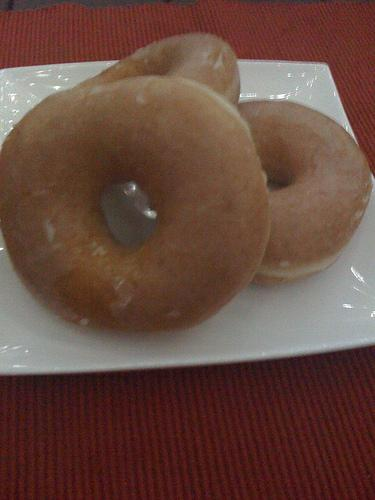Present a brief description of the food exhibited in the picture and its context. Three stacked donuts with glaze and holes in the center sit on a white plate, which lies on a distinct red table mat with ripples. Mention the central items present in the picture and their state. Three glazed doughnuts are placed together on a white square plate, resting on a red striped table mat. Point out the characteristics of the scene, particularly the doughnuts and the plate they are on. Three donuts with glaze and yellow edges are arranged on a glazed white square plate with light reflecting on its surface. Describe the setting where the delicious treats are served. A gray table holds a threaded red table mat with white, black, and red stripes, on which rests a square white plate carrying three doughnuts. Describe the image, highlighting its main features and how they all come together. Three doughnuts, touching each other and covered in glaze, rest on a glass square white plate with light reflections, surrounded by a red-striped mat. Talk about the primary objects in the photo, focusing on their appearance and surroundings. A trio of round donuts with white markings on top are showcased together on a reflective white plate atop a red cloth with wripples. Explain the color scheme and the visual features of the objects in the picture. The image displays three shiny glazed doughnuts on a square, glass white plate that reflects light, set on a red table mat with lines. Illustrate the arrangement of the doughnuts and the ambiance of the scene. The image captures three donuts, one fully facing the camera, and the other two angled, placed together on a white plate atop a red stripy cloth. Explain the food items in the image and how they are arranged. The image displays three glazed, round doughnuts with light brown color, stacked together on a white, glass plate. Discuss the key elements present in the picture, primarily the doughnuts. The image features three light brown, round and glazed doughnuts with holes in the middle, sitting closely on a white plate. 